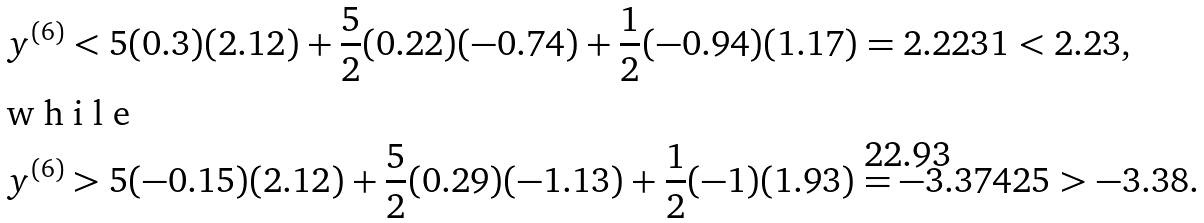<formula> <loc_0><loc_0><loc_500><loc_500>y ^ { ( 6 ) } & < 5 ( 0 . 3 ) ( 2 . 1 2 ) + \frac { 5 } { 2 } ( 0 . 2 2 ) ( - 0 . 7 4 ) + \frac { 1 } { 2 } ( - 0 . 9 4 ) ( 1 . 1 7 ) = 2 . 2 2 3 1 < 2 . 2 3 , \intertext { w h i l e } y ^ { ( 6 ) } & > 5 ( - 0 . 1 5 ) ( 2 . 1 2 ) + \frac { 5 } { 2 } ( 0 . 2 9 ) ( - 1 . 1 3 ) + \frac { 1 } { 2 } ( - 1 ) ( 1 . 9 3 ) = - 3 . 3 7 4 2 5 > - 3 . 3 8 .</formula> 